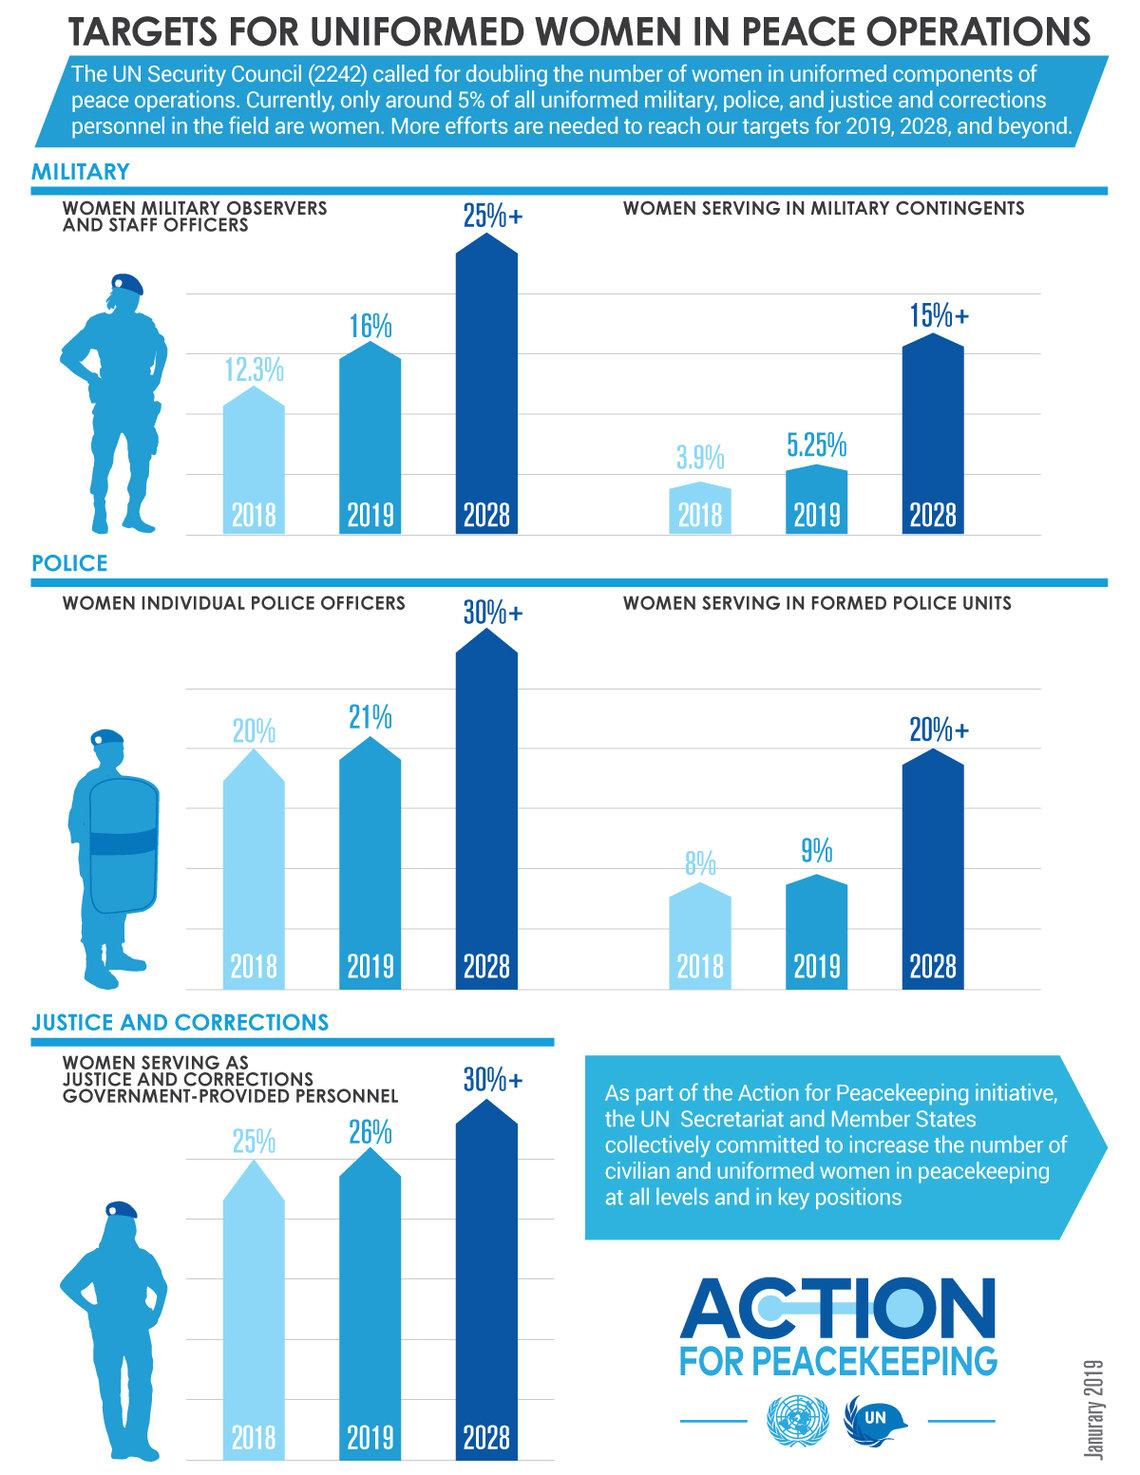Outline some significant characteristics in this image. The number of women military observers and staff officers increased by 3.7% from 2018 to 2019. In 2019, the number of female individual police officers increased by 1% compared to the previous year. According to data from 2018 to 2019, there was a 1% increase in the number of women serving as justice and corrections government-provided personnel. During the period from 2018 to 2019, there was a 1.35% increase in the number of women serving in military contingents. As of 2019, there was a 1% increase in the number of women serving in formed police units compared to the previous year. 